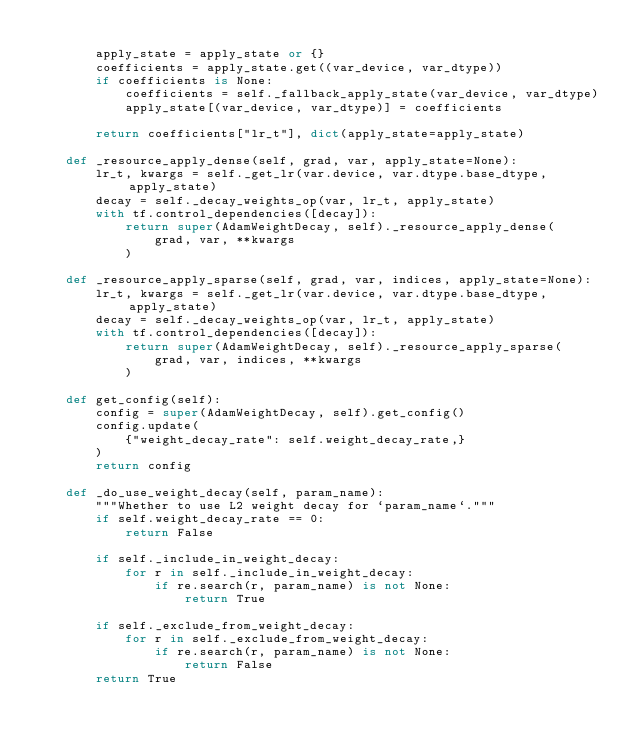<code> <loc_0><loc_0><loc_500><loc_500><_Python_>
        apply_state = apply_state or {}
        coefficients = apply_state.get((var_device, var_dtype))
        if coefficients is None:
            coefficients = self._fallback_apply_state(var_device, var_dtype)
            apply_state[(var_device, var_dtype)] = coefficients

        return coefficients["lr_t"], dict(apply_state=apply_state)

    def _resource_apply_dense(self, grad, var, apply_state=None):
        lr_t, kwargs = self._get_lr(var.device, var.dtype.base_dtype, apply_state)
        decay = self._decay_weights_op(var, lr_t, apply_state)
        with tf.control_dependencies([decay]):
            return super(AdamWeightDecay, self)._resource_apply_dense(
                grad, var, **kwargs
            )

    def _resource_apply_sparse(self, grad, var, indices, apply_state=None):
        lr_t, kwargs = self._get_lr(var.device, var.dtype.base_dtype, apply_state)
        decay = self._decay_weights_op(var, lr_t, apply_state)
        with tf.control_dependencies([decay]):
            return super(AdamWeightDecay, self)._resource_apply_sparse(
                grad, var, indices, **kwargs
            )

    def get_config(self):
        config = super(AdamWeightDecay, self).get_config()
        config.update(
            {"weight_decay_rate": self.weight_decay_rate,}
        )
        return config

    def _do_use_weight_decay(self, param_name):
        """Whether to use L2 weight decay for `param_name`."""
        if self.weight_decay_rate == 0:
            return False

        if self._include_in_weight_decay:
            for r in self._include_in_weight_decay:
                if re.search(r, param_name) is not None:
                    return True

        if self._exclude_from_weight_decay:
            for r in self._exclude_from_weight_decay:
                if re.search(r, param_name) is not None:
                    return False
        return True
</code> 